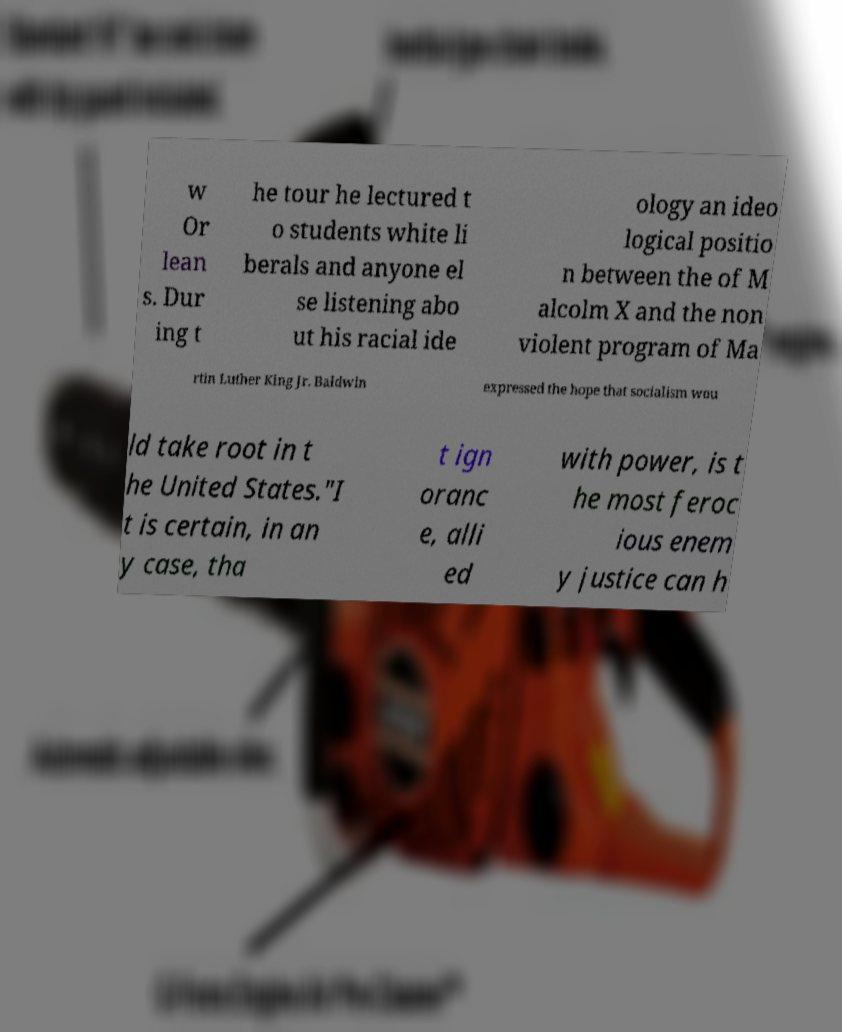I need the written content from this picture converted into text. Can you do that? w Or lean s. Dur ing t he tour he lectured t o students white li berals and anyone el se listening abo ut his racial ide ology an ideo logical positio n between the of M alcolm X and the non violent program of Ma rtin Luther King Jr. Baldwin expressed the hope that socialism wou ld take root in t he United States."I t is certain, in an y case, tha t ign oranc e, alli ed with power, is t he most feroc ious enem y justice can h 